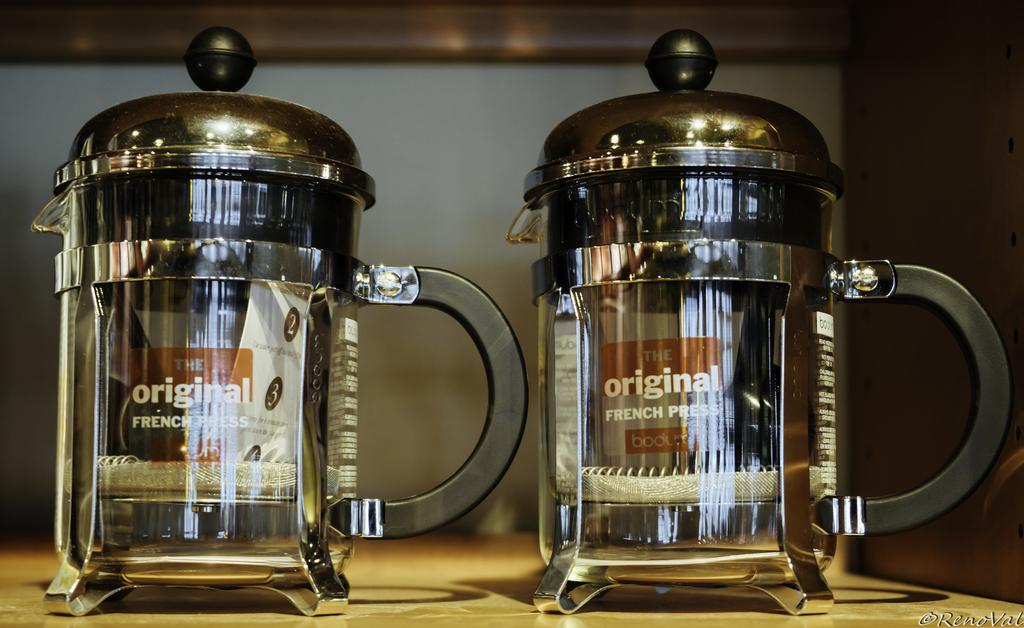What objects are present in the image? There are two glass jugs in the image. What are the glass jugs placed on? The glass jugs are on a surface. What type of poison is being stored in the glass jugs in the image? There is no indication of any poison in the image; it only shows two glass jugs on a surface. 